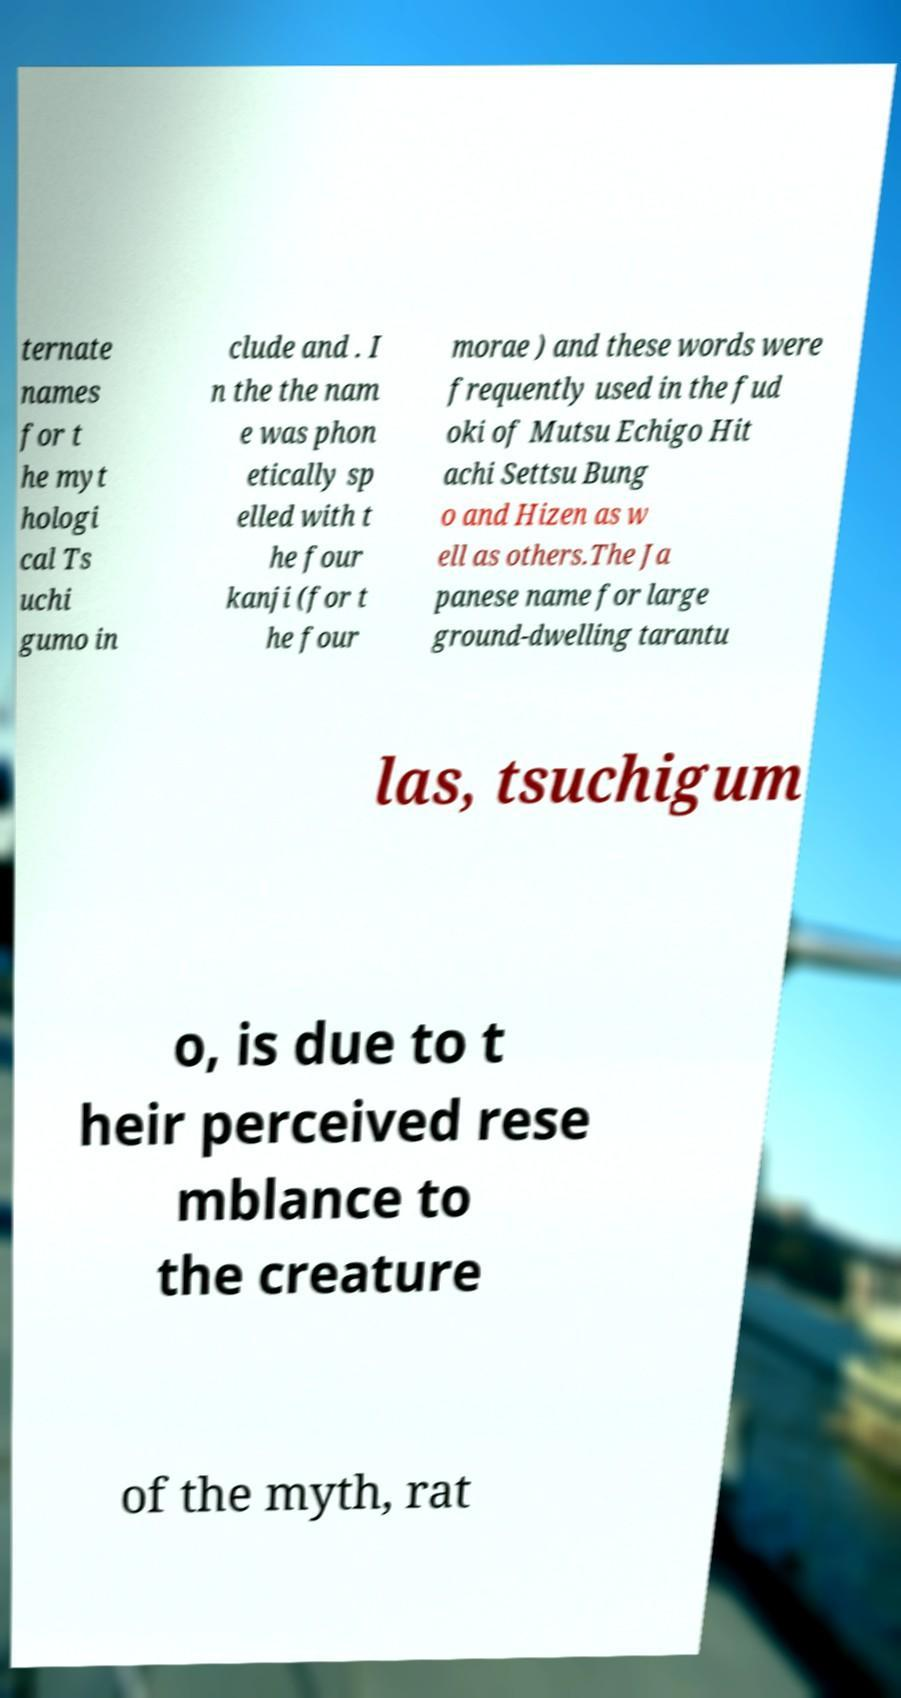For documentation purposes, I need the text within this image transcribed. Could you provide that? ternate names for t he myt hologi cal Ts uchi gumo in clude and . I n the the nam e was phon etically sp elled with t he four kanji (for t he four morae ) and these words were frequently used in the fud oki of Mutsu Echigo Hit achi Settsu Bung o and Hizen as w ell as others.The Ja panese name for large ground-dwelling tarantu las, tsuchigum o, is due to t heir perceived rese mblance to the creature of the myth, rat 